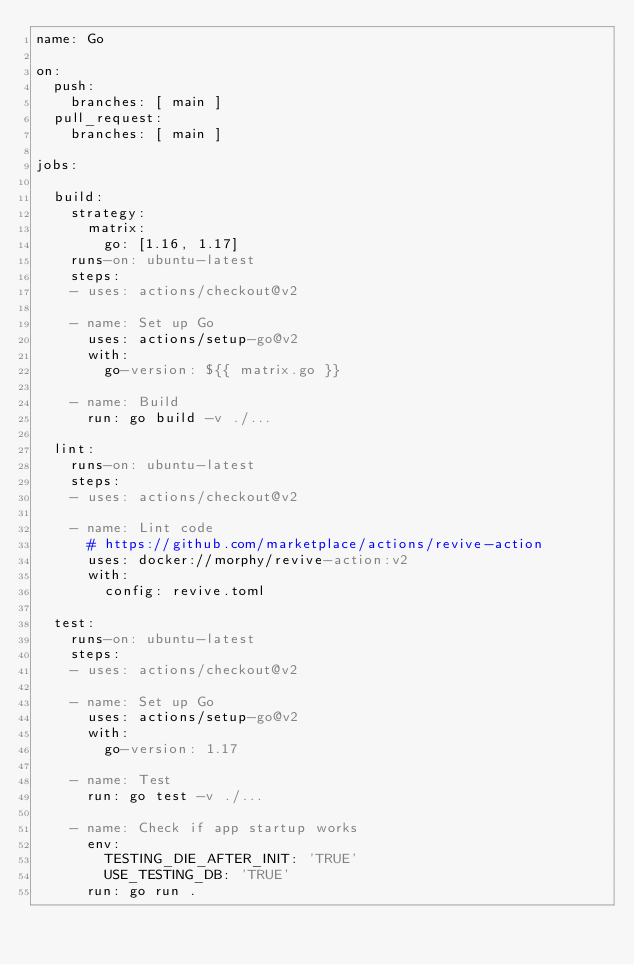Convert code to text. <code><loc_0><loc_0><loc_500><loc_500><_YAML_>name: Go

on:
  push:
    branches: [ main ]
  pull_request:
    branches: [ main ]

jobs:

  build:
    strategy:
      matrix:
        go: [1.16, 1.17]
    runs-on: ubuntu-latest
    steps:
    - uses: actions/checkout@v2

    - name: Set up Go
      uses: actions/setup-go@v2
      with:
        go-version: ${{ matrix.go }}

    - name: Build
      run: go build -v ./...

  lint:
    runs-on: ubuntu-latest
    steps:
    - uses: actions/checkout@v2

    - name: Lint code
      # https://github.com/marketplace/actions/revive-action
      uses: docker://morphy/revive-action:v2
      with:
        config: revive.toml

  test:
    runs-on: ubuntu-latest
    steps:
    - uses: actions/checkout@v2

    - name: Set up Go
      uses: actions/setup-go@v2
      with:
        go-version: 1.17

    - name: Test
      run: go test -v ./...

    - name: Check if app startup works
      env:
        TESTING_DIE_AFTER_INIT: 'TRUE'
        USE_TESTING_DB: 'TRUE'
      run: go run .
</code> 